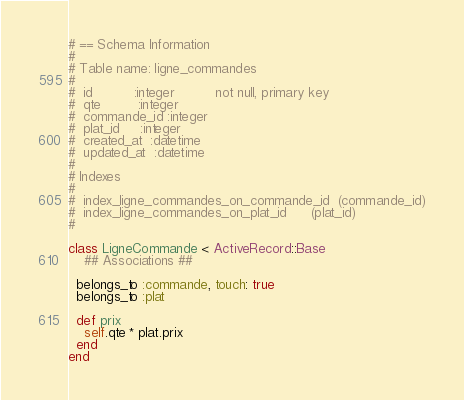<code> <loc_0><loc_0><loc_500><loc_500><_Ruby_># == Schema Information
#
# Table name: ligne_commandes
#
#  id          :integer          not null, primary key
#  qte         :integer
#  commande_id :integer
#  plat_id     :integer
#  created_at  :datetime
#  updated_at  :datetime
#
# Indexes
#
#  index_ligne_commandes_on_commande_id  (commande_id)
#  index_ligne_commandes_on_plat_id      (plat_id)
#

class LigneCommande < ActiveRecord::Base
	## Associations ##

  belongs_to :commande, touch: true
  belongs_to :plat

  def prix
    self.qte * plat.prix
  end
end
</code> 